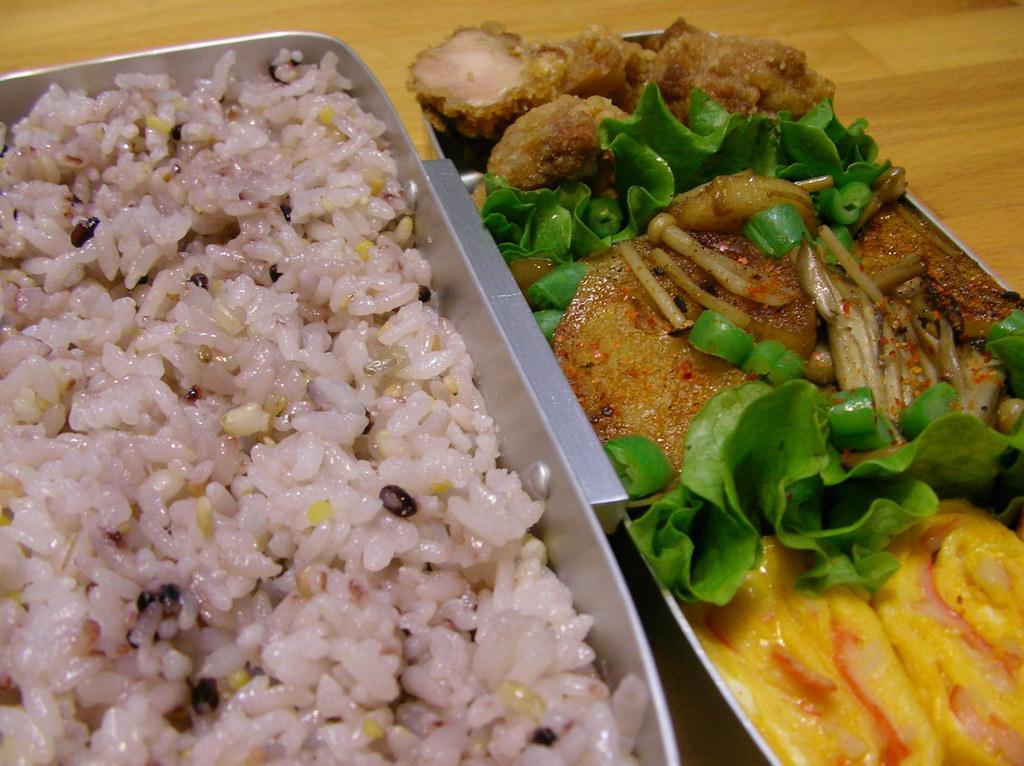How would you summarize this image in a sentence or two? In the picture we can see a wooden plank on it, we can see two trays, in one tray we can see boiled rice and in second try we can see some curry with some vegetable garnish on it. 